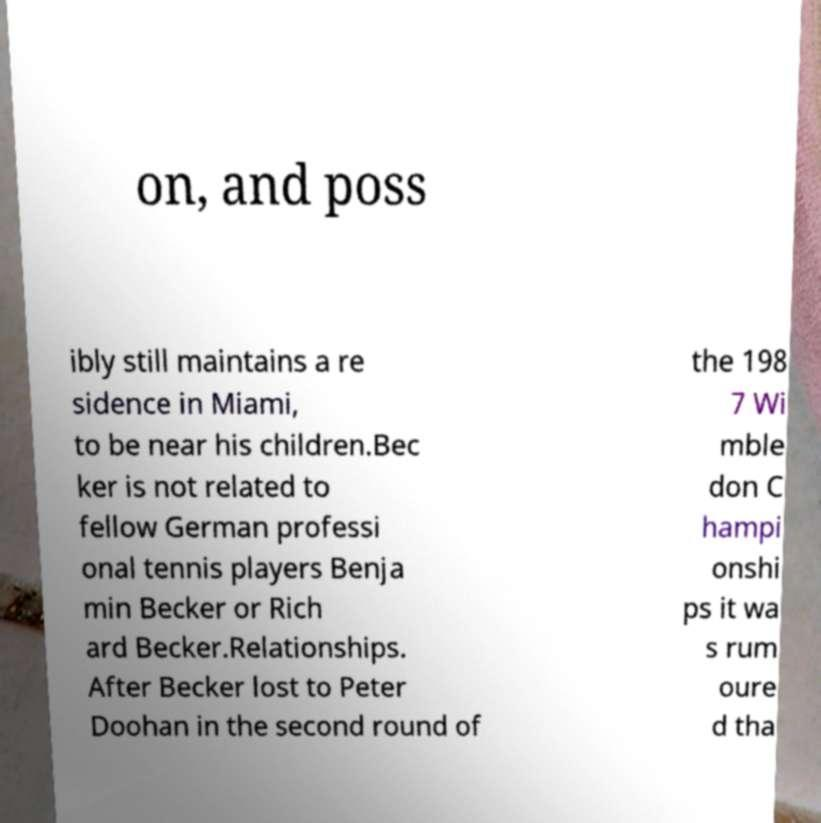What messages or text are displayed in this image? I need them in a readable, typed format. on, and poss ibly still maintains a re sidence in Miami, to be near his children.Bec ker is not related to fellow German professi onal tennis players Benja min Becker or Rich ard Becker.Relationships. After Becker lost to Peter Doohan in the second round of the 198 7 Wi mble don C hampi onshi ps it wa s rum oure d tha 